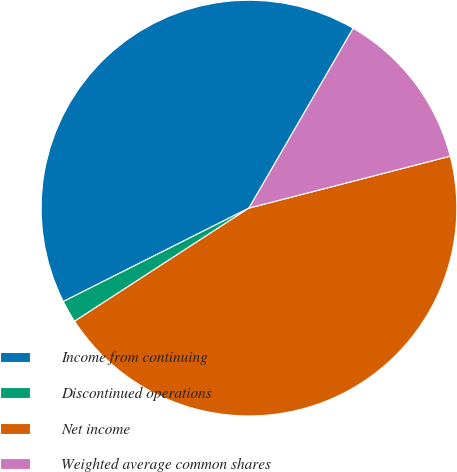Convert chart. <chart><loc_0><loc_0><loc_500><loc_500><pie_chart><fcel>Income from continuing<fcel>Discontinued operations<fcel>Net income<fcel>Weighted average common shares<nl><fcel>40.78%<fcel>1.74%<fcel>44.86%<fcel>12.62%<nl></chart> 